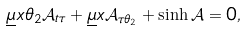Convert formula to latex. <formula><loc_0><loc_0><loc_500><loc_500>\underline { \mu } x \theta _ { 2 } { \mathcal { A } } _ { t \tau } + \underline { \mu } x { \mathcal { A } } _ { \tau \theta _ { 2 } } + \sinh { \mathcal { A } } = 0 ,</formula> 